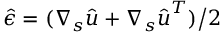<formula> <loc_0><loc_0><loc_500><loc_500>{ \hat { \epsilon } } = ( \nabla _ { s } { \hat { u } } + \nabla _ { s } { \hat { u } } ^ { T } ) \Big / 2</formula> 